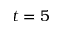<formula> <loc_0><loc_0><loc_500><loc_500>t = 5</formula> 